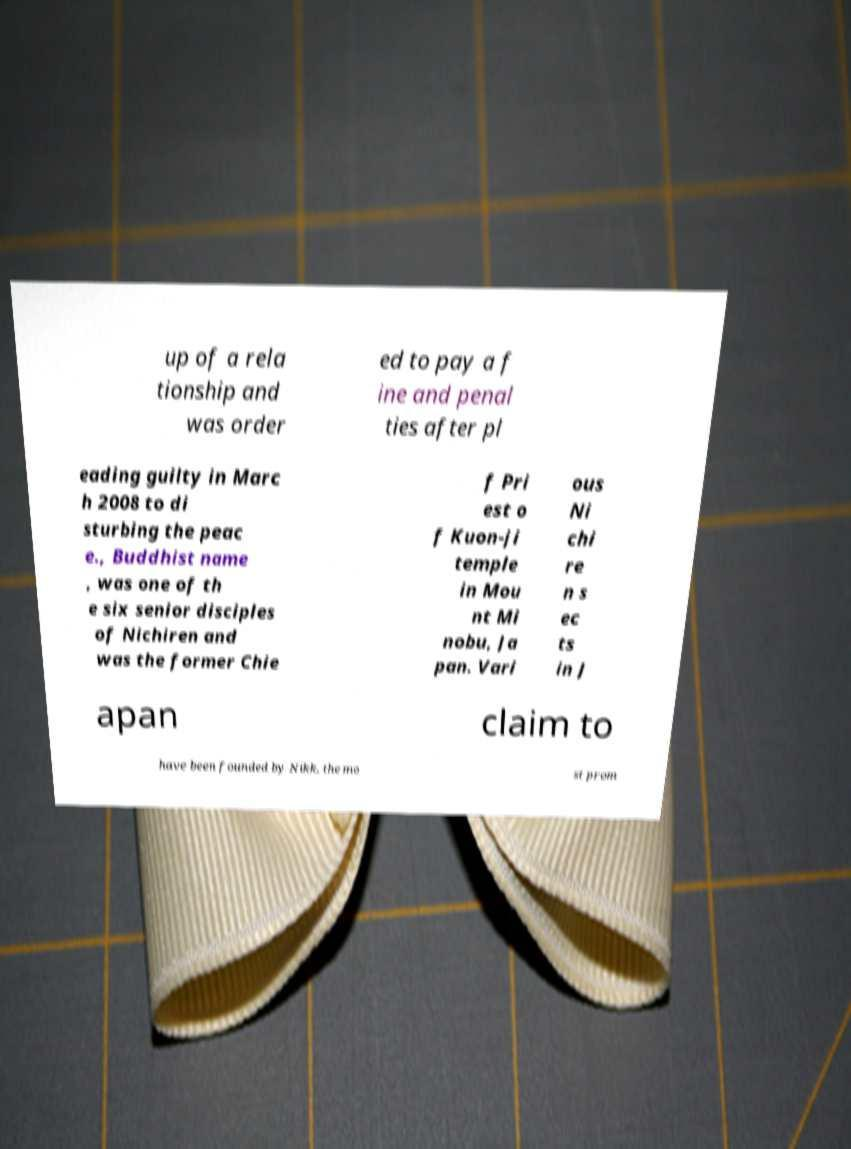Can you read and provide the text displayed in the image?This photo seems to have some interesting text. Can you extract and type it out for me? up of a rela tionship and was order ed to pay a f ine and penal ties after pl eading guilty in Marc h 2008 to di sturbing the peac e., Buddhist name , was one of th e six senior disciples of Nichiren and was the former Chie f Pri est o f Kuon-ji temple in Mou nt Mi nobu, Ja pan. Vari ous Ni chi re n s ec ts in J apan claim to have been founded by Nikk, the mo st prom 